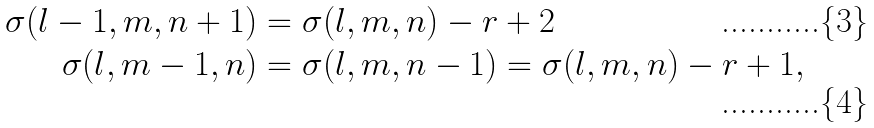<formula> <loc_0><loc_0><loc_500><loc_500>\sigma ( l - 1 , m , n + 1 ) & = \sigma ( l , m , n ) - r + 2 \\ \sigma ( l , m - 1 , n ) & = \sigma ( l , m , n - 1 ) = \sigma ( l , m , n ) - r + 1 ,</formula> 